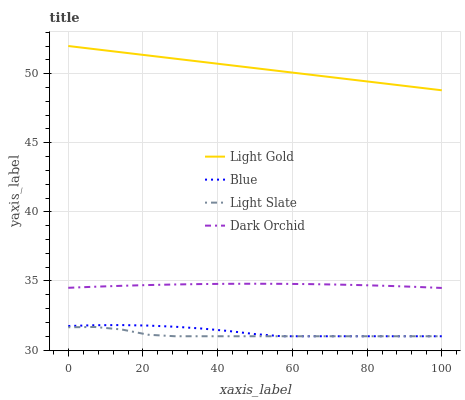Does Light Slate have the minimum area under the curve?
Answer yes or no. Yes. Does Light Gold have the maximum area under the curve?
Answer yes or no. Yes. Does Light Gold have the minimum area under the curve?
Answer yes or no. No. Does Light Slate have the maximum area under the curve?
Answer yes or no. No. Is Light Gold the smoothest?
Answer yes or no. Yes. Is Light Slate the roughest?
Answer yes or no. Yes. Is Light Slate the smoothest?
Answer yes or no. No. Is Light Gold the roughest?
Answer yes or no. No. Does Blue have the lowest value?
Answer yes or no. Yes. Does Light Gold have the lowest value?
Answer yes or no. No. Does Light Gold have the highest value?
Answer yes or no. Yes. Does Light Slate have the highest value?
Answer yes or no. No. Is Light Slate less than Dark Orchid?
Answer yes or no. Yes. Is Dark Orchid greater than Blue?
Answer yes or no. Yes. Does Blue intersect Light Slate?
Answer yes or no. Yes. Is Blue less than Light Slate?
Answer yes or no. No. Is Blue greater than Light Slate?
Answer yes or no. No. Does Light Slate intersect Dark Orchid?
Answer yes or no. No. 